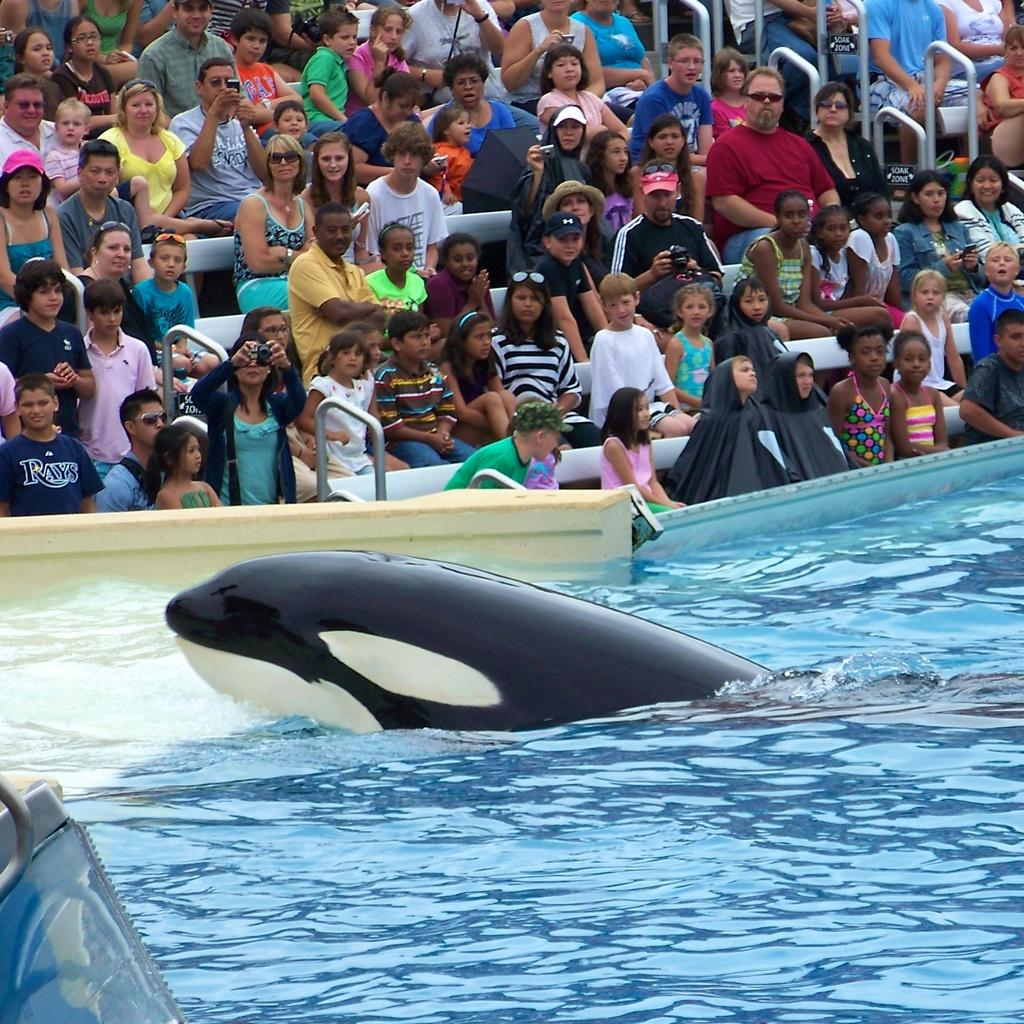What animal can be seen in the pool in the image? There is a dolphin in the pool in the image. What are the people doing in the image? People are sitting and watching the show in the image. Are any of the people taking pictures? Yes, some people are clicking photographs in the image. What type of seed is being planted in the pot by the dolphin? There is no pot or seed present in the image; it features a dolphin in a pool and people watching a show. Can you tell me the name of the dolphin's sister in the image? There is no mention of a sister or any other dolphins in the image. 